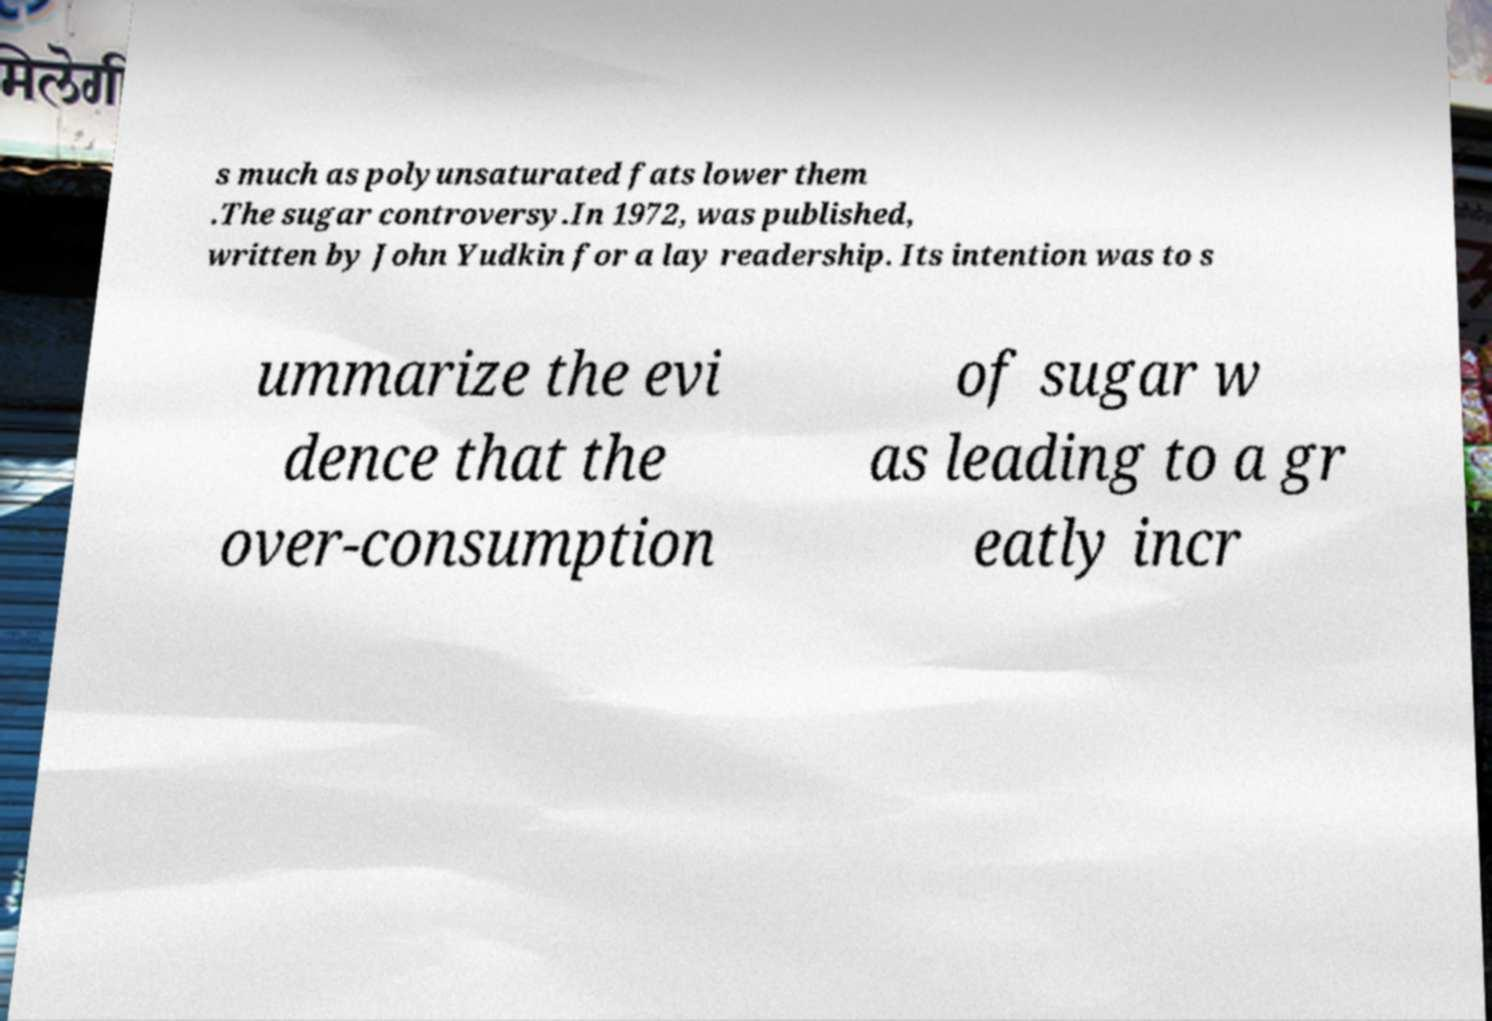For documentation purposes, I need the text within this image transcribed. Could you provide that? s much as polyunsaturated fats lower them .The sugar controversy.In 1972, was published, written by John Yudkin for a lay readership. Its intention was to s ummarize the evi dence that the over-consumption of sugar w as leading to a gr eatly incr 